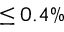<formula> <loc_0><loc_0><loc_500><loc_500>\leq 0 . 4 \%</formula> 